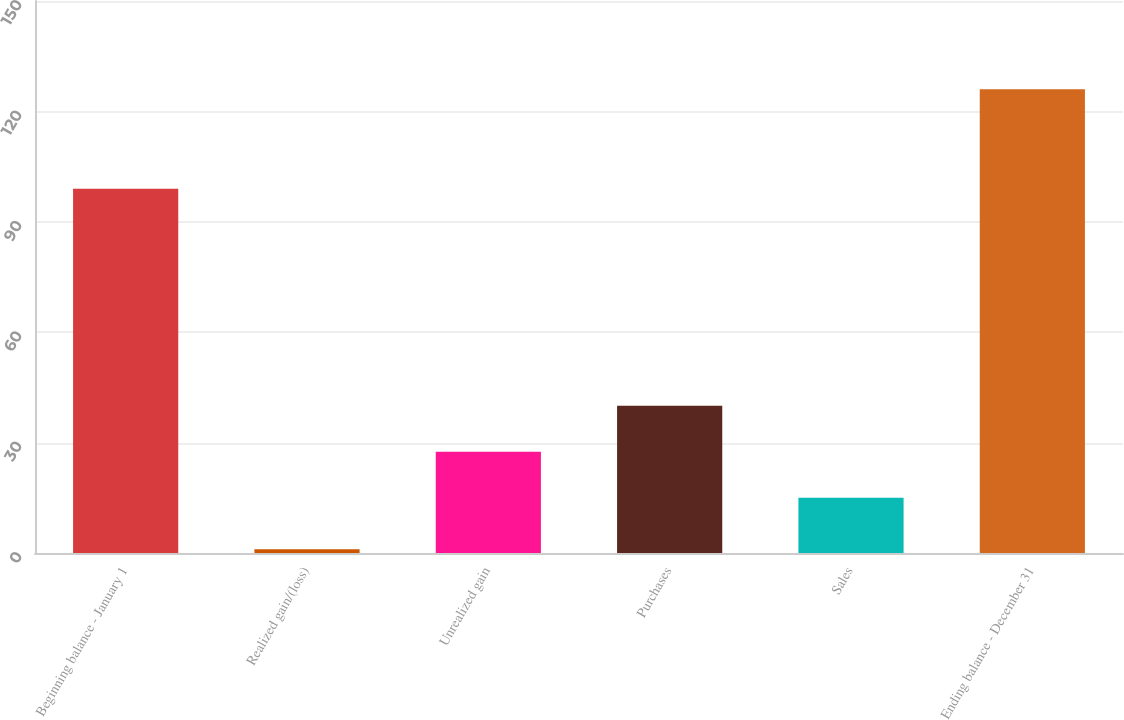Convert chart to OTSL. <chart><loc_0><loc_0><loc_500><loc_500><bar_chart><fcel>Beginning balance - January 1<fcel>Realized gain/(loss)<fcel>Unrealized gain<fcel>Purchases<fcel>Sales<fcel>Ending balance - December 31<nl><fcel>99<fcel>1<fcel>27.5<fcel>40<fcel>15<fcel>126<nl></chart> 